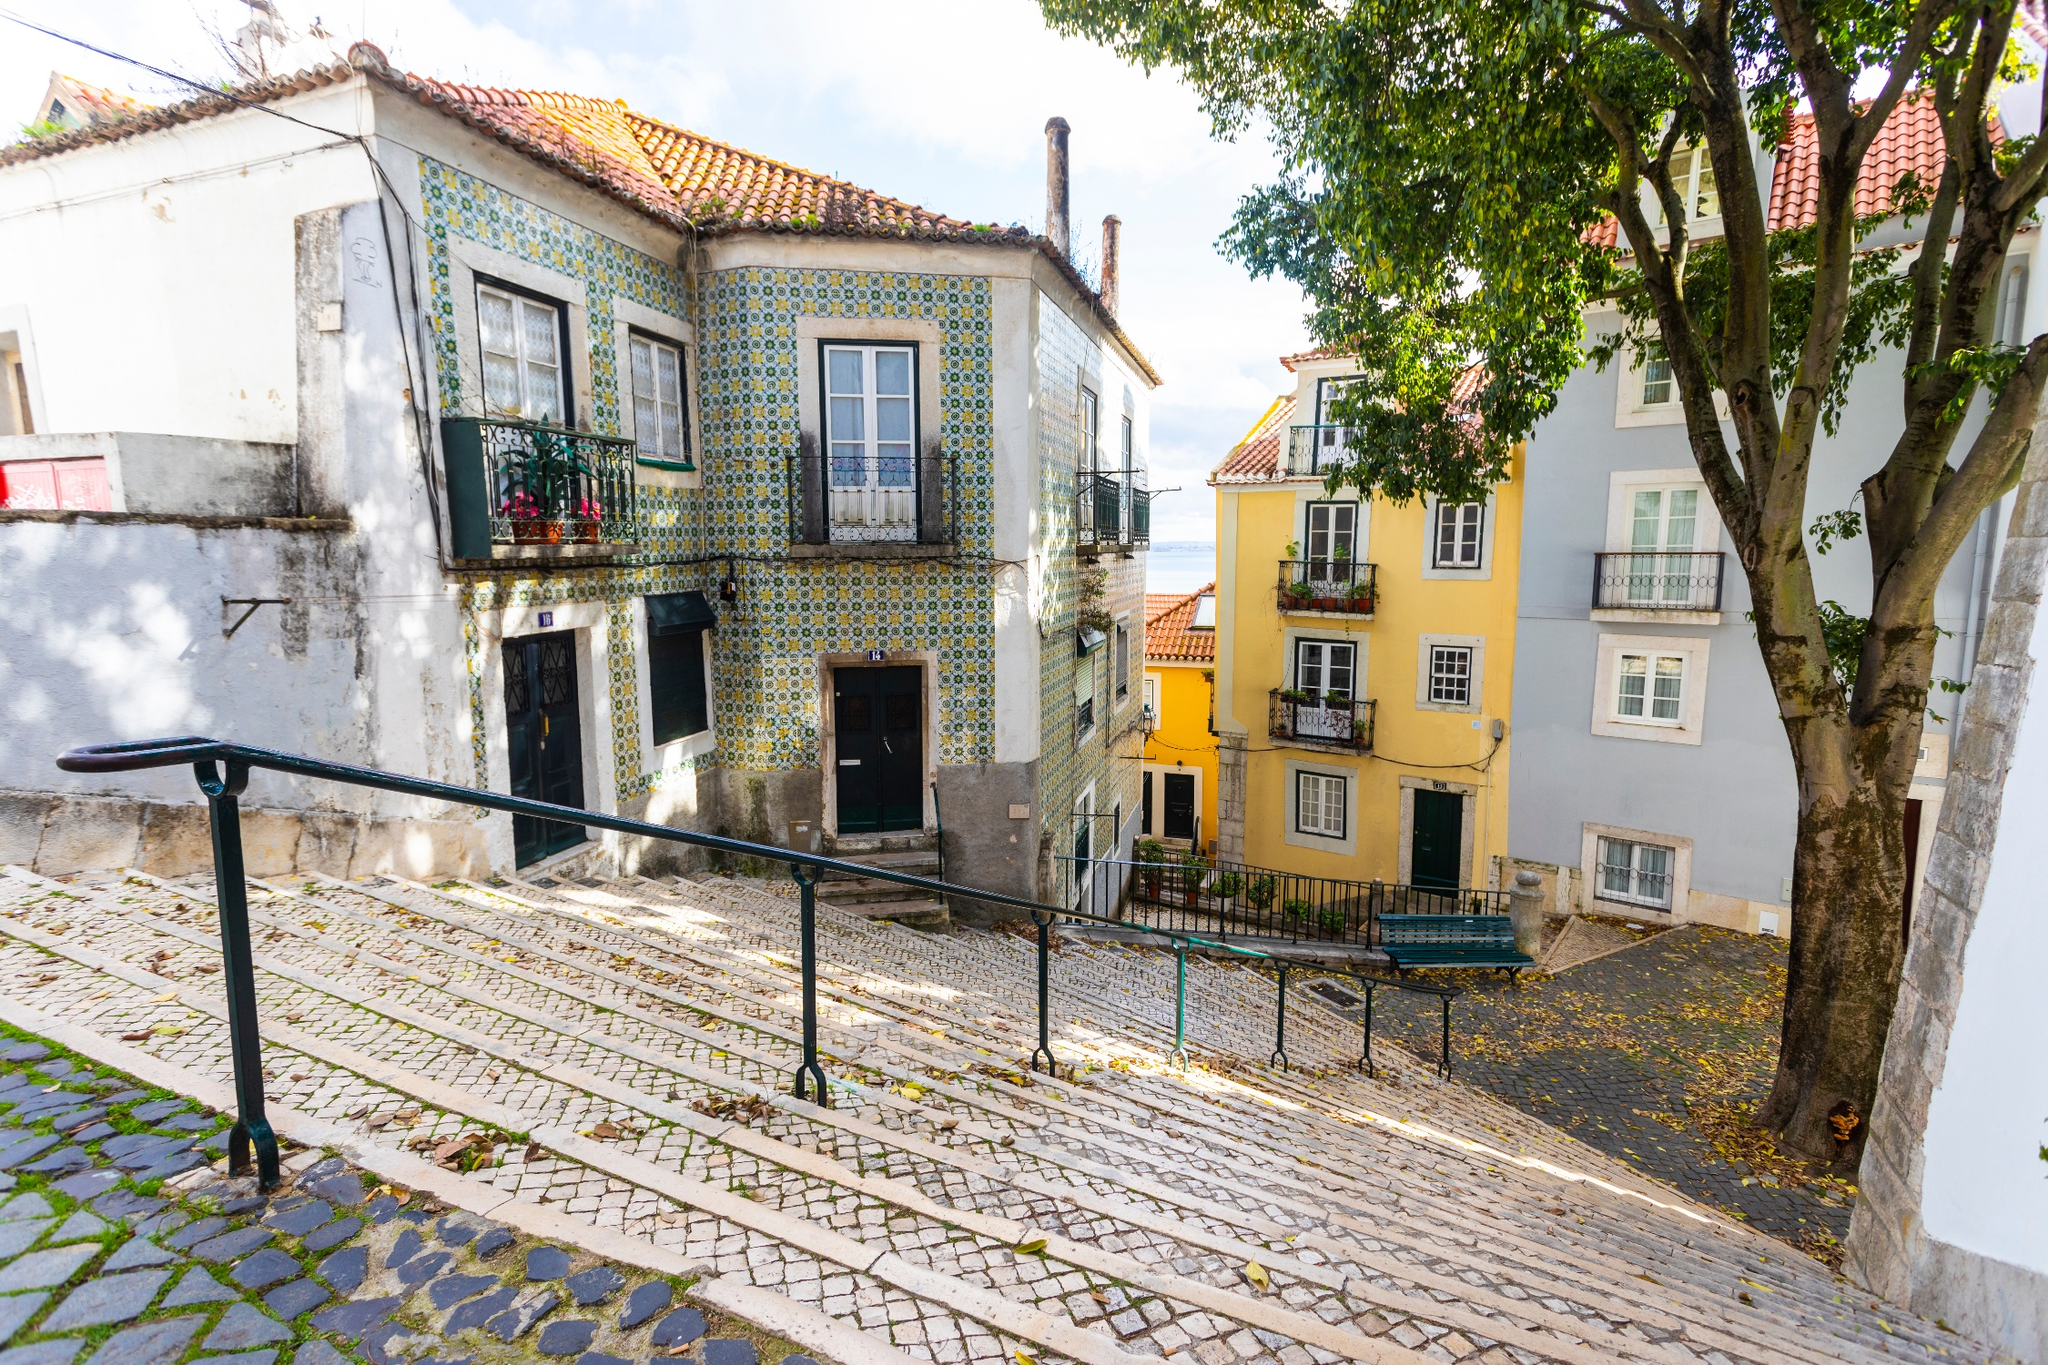Can you describe the mood conveyed by this street scene? The mood conveyed by this street scene is one of calm and quaint charm. The soft sunlight illuminates the vibrantly tiled facades, creating a welcoming and warm atmosphere. The gentle gradient of the street, combined with the tranquil surroundings, evokes a sense of peacefulness and a slow pace of life. This setting invites one to take a leisurely stroll, appreciating the beauty of everyday life in this historic part of Lisbon. What kind of activities might be happening around this area? In this area, you might see residents going about their daily routines, such as walking to local shops, cafes, or markets. Tourists could be exploring the historic architecture and capturing photos of the beautifully tiled buildings. The steps might be a place where people pause for a moment to enjoy the view or check their maps. Additionally, the nearby trees and benches offer spots for locals and visitors to relax, have a conversation, or simply enjoy the pleasant ambiance. Imagine this street at night. Describe the scene. At night, the street transforms into a magical scene under the gentle glow of street lamps. The cobblestones gleam softly in the light, and the tiles on the buildings reflect the warm hues, creating a cozy and intimate atmosphere. The chatter of nearby residents might fill the air as they return home or enjoy evening outings. Soft music from a distant cafe or the sound of a nearby church bell might add to the serene nighttime ambiance. Shadows of the trees play across the walls and pavement, adding a layer of depth and mystery to this enchanting urban setting. If this street could tell a story, what would it say? If this street could tell a story, it would recount the tales of countless generations who have walked its cobblestones. It would speak of the artisans who crafted the intricate tiles that adorn its buildings, the families who have lived and loved in the houses with the red roofs, and the many travelers who have marveled at its beauty. It would tell of quiet mornings filled with the scent of fresh bread and coffee, vibrant afternoons bustling with local markets, and serene evenings where the street lies peacefully under a blanket of stars. This street has witnessed the ebb and flow of time, capturing the essence of Lisbon's rich history and the everyday moments that make it so special. 